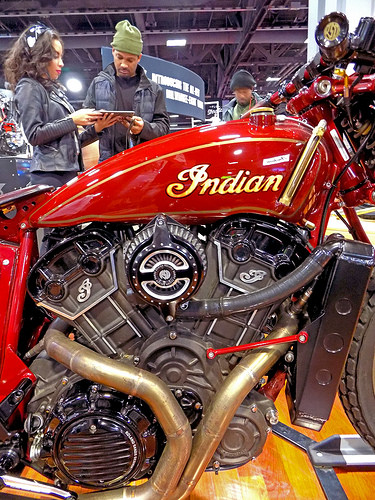<image>
Is there a motorcycle in front of the man? Yes. The motorcycle is positioned in front of the man, appearing closer to the camera viewpoint. 